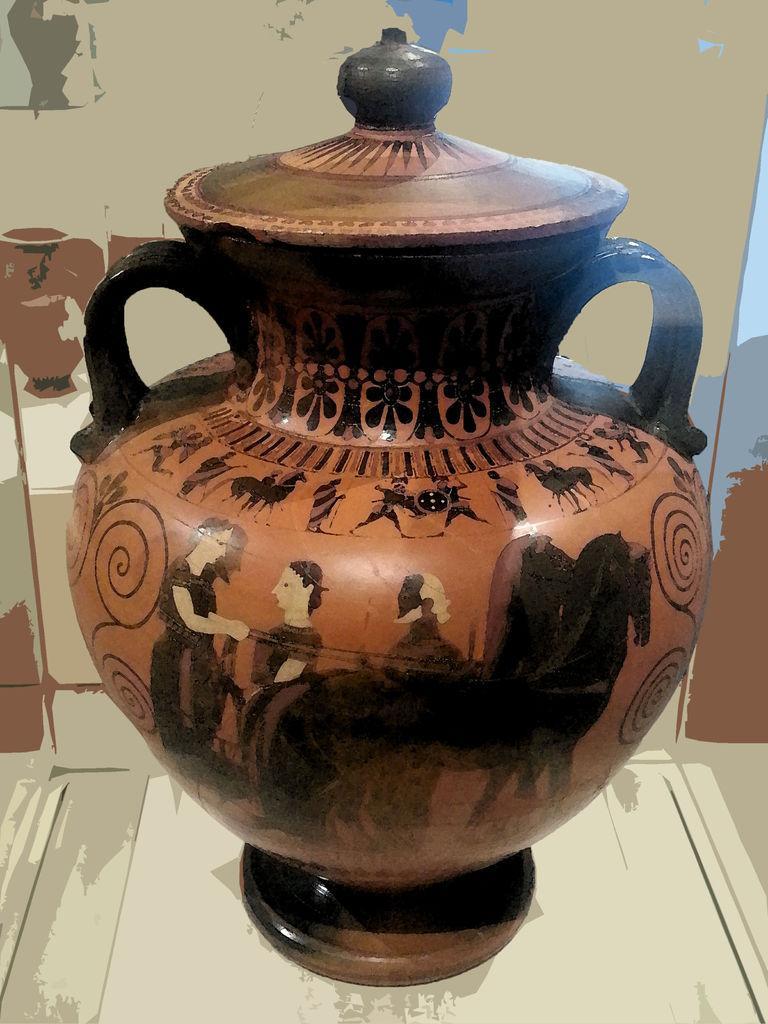How would you summarize this image in a sentence or two? In this image I can see a vase with a lid on it. On this there are few paintings. In the background there is a wall. 